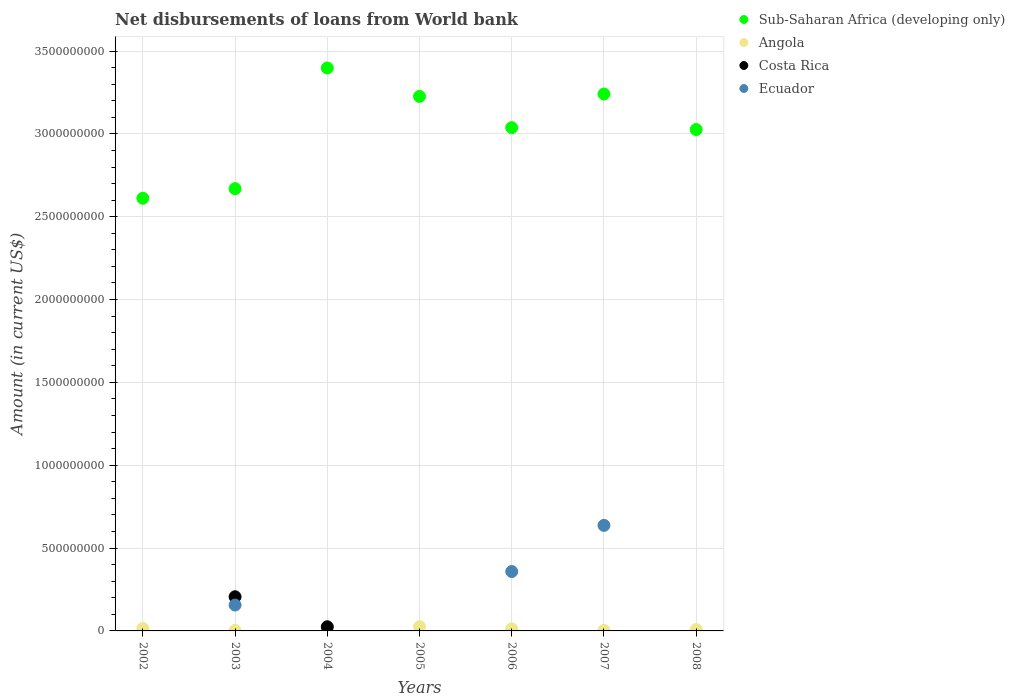What is the amount of loan disbursed from World Bank in Sub-Saharan Africa (developing only) in 2007?
Your answer should be very brief. 3.24e+09. Across all years, what is the maximum amount of loan disbursed from World Bank in Ecuador?
Offer a terse response. 6.37e+08. Across all years, what is the minimum amount of loan disbursed from World Bank in Sub-Saharan Africa (developing only)?
Ensure brevity in your answer.  2.61e+09. What is the total amount of loan disbursed from World Bank in Sub-Saharan Africa (developing only) in the graph?
Your response must be concise. 2.12e+1. What is the difference between the amount of loan disbursed from World Bank in Sub-Saharan Africa (developing only) in 2002 and that in 2008?
Offer a terse response. -4.15e+08. What is the difference between the amount of loan disbursed from World Bank in Costa Rica in 2004 and the amount of loan disbursed from World Bank in Angola in 2005?
Offer a very short reply. -5.76e+05. What is the average amount of loan disbursed from World Bank in Costa Rica per year?
Offer a very short reply. 3.30e+07. In the year 2003, what is the difference between the amount of loan disbursed from World Bank in Costa Rica and amount of loan disbursed from World Bank in Ecuador?
Provide a succinct answer. 5.00e+07. What is the ratio of the amount of loan disbursed from World Bank in Angola in 2004 to that in 2008?
Your answer should be very brief. 2.02. Is the amount of loan disbursed from World Bank in Ecuador in 2006 less than that in 2007?
Make the answer very short. Yes. What is the difference between the highest and the second highest amount of loan disbursed from World Bank in Sub-Saharan Africa (developing only)?
Keep it short and to the point. 1.57e+08. What is the difference between the highest and the lowest amount of loan disbursed from World Bank in Ecuador?
Give a very brief answer. 6.37e+08. Is it the case that in every year, the sum of the amount of loan disbursed from World Bank in Ecuador and amount of loan disbursed from World Bank in Angola  is greater than the sum of amount of loan disbursed from World Bank in Costa Rica and amount of loan disbursed from World Bank in Sub-Saharan Africa (developing only)?
Your answer should be very brief. Yes. Does the amount of loan disbursed from World Bank in Costa Rica monotonically increase over the years?
Your answer should be compact. No. Is the amount of loan disbursed from World Bank in Sub-Saharan Africa (developing only) strictly less than the amount of loan disbursed from World Bank in Angola over the years?
Ensure brevity in your answer.  No. How many dotlines are there?
Provide a succinct answer. 4. Are the values on the major ticks of Y-axis written in scientific E-notation?
Offer a terse response. No. Does the graph contain grids?
Provide a short and direct response. Yes. How many legend labels are there?
Provide a succinct answer. 4. What is the title of the graph?
Your answer should be very brief. Net disbursements of loans from World bank. What is the label or title of the X-axis?
Offer a terse response. Years. What is the label or title of the Y-axis?
Offer a terse response. Amount (in current US$). What is the Amount (in current US$) of Sub-Saharan Africa (developing only) in 2002?
Ensure brevity in your answer.  2.61e+09. What is the Amount (in current US$) in Angola in 2002?
Give a very brief answer. 1.49e+07. What is the Amount (in current US$) of Costa Rica in 2002?
Your answer should be very brief. 0. What is the Amount (in current US$) of Sub-Saharan Africa (developing only) in 2003?
Offer a very short reply. 2.67e+09. What is the Amount (in current US$) in Angola in 2003?
Your answer should be compact. 3.14e+06. What is the Amount (in current US$) of Costa Rica in 2003?
Your answer should be very brief. 2.06e+08. What is the Amount (in current US$) in Ecuador in 2003?
Your answer should be very brief. 1.56e+08. What is the Amount (in current US$) in Sub-Saharan Africa (developing only) in 2004?
Your answer should be compact. 3.40e+09. What is the Amount (in current US$) in Angola in 2004?
Provide a succinct answer. 1.61e+07. What is the Amount (in current US$) of Costa Rica in 2004?
Make the answer very short. 2.51e+07. What is the Amount (in current US$) in Sub-Saharan Africa (developing only) in 2005?
Provide a succinct answer. 3.23e+09. What is the Amount (in current US$) in Angola in 2005?
Your answer should be compact. 2.57e+07. What is the Amount (in current US$) of Ecuador in 2005?
Your response must be concise. 0. What is the Amount (in current US$) of Sub-Saharan Africa (developing only) in 2006?
Keep it short and to the point. 3.04e+09. What is the Amount (in current US$) of Angola in 2006?
Provide a succinct answer. 1.25e+07. What is the Amount (in current US$) of Costa Rica in 2006?
Keep it short and to the point. 0. What is the Amount (in current US$) in Ecuador in 2006?
Provide a succinct answer. 3.58e+08. What is the Amount (in current US$) in Sub-Saharan Africa (developing only) in 2007?
Keep it short and to the point. 3.24e+09. What is the Amount (in current US$) of Angola in 2007?
Offer a terse response. 3.36e+06. What is the Amount (in current US$) in Ecuador in 2007?
Ensure brevity in your answer.  6.37e+08. What is the Amount (in current US$) in Sub-Saharan Africa (developing only) in 2008?
Offer a very short reply. 3.03e+09. What is the Amount (in current US$) of Angola in 2008?
Provide a short and direct response. 7.97e+06. Across all years, what is the maximum Amount (in current US$) of Sub-Saharan Africa (developing only)?
Ensure brevity in your answer.  3.40e+09. Across all years, what is the maximum Amount (in current US$) in Angola?
Make the answer very short. 2.57e+07. Across all years, what is the maximum Amount (in current US$) in Costa Rica?
Ensure brevity in your answer.  2.06e+08. Across all years, what is the maximum Amount (in current US$) in Ecuador?
Make the answer very short. 6.37e+08. Across all years, what is the minimum Amount (in current US$) of Sub-Saharan Africa (developing only)?
Your response must be concise. 2.61e+09. Across all years, what is the minimum Amount (in current US$) in Angola?
Ensure brevity in your answer.  3.14e+06. Across all years, what is the minimum Amount (in current US$) in Costa Rica?
Provide a succinct answer. 0. What is the total Amount (in current US$) in Sub-Saharan Africa (developing only) in the graph?
Offer a very short reply. 2.12e+1. What is the total Amount (in current US$) in Angola in the graph?
Provide a succinct answer. 8.37e+07. What is the total Amount (in current US$) in Costa Rica in the graph?
Make the answer very short. 2.31e+08. What is the total Amount (in current US$) in Ecuador in the graph?
Provide a succinct answer. 1.15e+09. What is the difference between the Amount (in current US$) in Sub-Saharan Africa (developing only) in 2002 and that in 2003?
Give a very brief answer. -5.79e+07. What is the difference between the Amount (in current US$) of Angola in 2002 and that in 2003?
Ensure brevity in your answer.  1.18e+07. What is the difference between the Amount (in current US$) of Sub-Saharan Africa (developing only) in 2002 and that in 2004?
Ensure brevity in your answer.  -7.86e+08. What is the difference between the Amount (in current US$) in Angola in 2002 and that in 2004?
Give a very brief answer. -1.17e+06. What is the difference between the Amount (in current US$) in Sub-Saharan Africa (developing only) in 2002 and that in 2005?
Make the answer very short. -6.15e+08. What is the difference between the Amount (in current US$) in Angola in 2002 and that in 2005?
Make the answer very short. -1.07e+07. What is the difference between the Amount (in current US$) of Sub-Saharan Africa (developing only) in 2002 and that in 2006?
Your answer should be compact. -4.26e+08. What is the difference between the Amount (in current US$) in Angola in 2002 and that in 2006?
Your answer should be compact. 2.41e+06. What is the difference between the Amount (in current US$) of Sub-Saharan Africa (developing only) in 2002 and that in 2007?
Ensure brevity in your answer.  -6.29e+08. What is the difference between the Amount (in current US$) in Angola in 2002 and that in 2007?
Your answer should be very brief. 1.16e+07. What is the difference between the Amount (in current US$) in Sub-Saharan Africa (developing only) in 2002 and that in 2008?
Give a very brief answer. -4.15e+08. What is the difference between the Amount (in current US$) of Angola in 2002 and that in 2008?
Provide a succinct answer. 6.97e+06. What is the difference between the Amount (in current US$) of Sub-Saharan Africa (developing only) in 2003 and that in 2004?
Provide a short and direct response. -7.28e+08. What is the difference between the Amount (in current US$) of Angola in 2003 and that in 2004?
Keep it short and to the point. -1.30e+07. What is the difference between the Amount (in current US$) of Costa Rica in 2003 and that in 2004?
Give a very brief answer. 1.81e+08. What is the difference between the Amount (in current US$) of Sub-Saharan Africa (developing only) in 2003 and that in 2005?
Make the answer very short. -5.57e+08. What is the difference between the Amount (in current US$) in Angola in 2003 and that in 2005?
Ensure brevity in your answer.  -2.25e+07. What is the difference between the Amount (in current US$) in Sub-Saharan Africa (developing only) in 2003 and that in 2006?
Your answer should be compact. -3.68e+08. What is the difference between the Amount (in current US$) in Angola in 2003 and that in 2006?
Give a very brief answer. -9.39e+06. What is the difference between the Amount (in current US$) of Ecuador in 2003 and that in 2006?
Give a very brief answer. -2.02e+08. What is the difference between the Amount (in current US$) in Sub-Saharan Africa (developing only) in 2003 and that in 2007?
Your answer should be very brief. -5.71e+08. What is the difference between the Amount (in current US$) of Angola in 2003 and that in 2007?
Your answer should be compact. -2.14e+05. What is the difference between the Amount (in current US$) in Ecuador in 2003 and that in 2007?
Give a very brief answer. -4.81e+08. What is the difference between the Amount (in current US$) in Sub-Saharan Africa (developing only) in 2003 and that in 2008?
Give a very brief answer. -3.57e+08. What is the difference between the Amount (in current US$) in Angola in 2003 and that in 2008?
Your answer should be compact. -4.82e+06. What is the difference between the Amount (in current US$) of Sub-Saharan Africa (developing only) in 2004 and that in 2005?
Your answer should be very brief. 1.71e+08. What is the difference between the Amount (in current US$) in Angola in 2004 and that in 2005?
Your response must be concise. -9.56e+06. What is the difference between the Amount (in current US$) in Sub-Saharan Africa (developing only) in 2004 and that in 2006?
Your answer should be compact. 3.60e+08. What is the difference between the Amount (in current US$) in Angola in 2004 and that in 2006?
Make the answer very short. 3.57e+06. What is the difference between the Amount (in current US$) of Sub-Saharan Africa (developing only) in 2004 and that in 2007?
Provide a succinct answer. 1.57e+08. What is the difference between the Amount (in current US$) of Angola in 2004 and that in 2007?
Keep it short and to the point. 1.28e+07. What is the difference between the Amount (in current US$) in Sub-Saharan Africa (developing only) in 2004 and that in 2008?
Your answer should be compact. 3.71e+08. What is the difference between the Amount (in current US$) in Angola in 2004 and that in 2008?
Make the answer very short. 8.14e+06. What is the difference between the Amount (in current US$) in Sub-Saharan Africa (developing only) in 2005 and that in 2006?
Your answer should be compact. 1.89e+08. What is the difference between the Amount (in current US$) of Angola in 2005 and that in 2006?
Ensure brevity in your answer.  1.31e+07. What is the difference between the Amount (in current US$) in Sub-Saharan Africa (developing only) in 2005 and that in 2007?
Keep it short and to the point. -1.42e+07. What is the difference between the Amount (in current US$) in Angola in 2005 and that in 2007?
Give a very brief answer. 2.23e+07. What is the difference between the Amount (in current US$) of Sub-Saharan Africa (developing only) in 2005 and that in 2008?
Ensure brevity in your answer.  2.00e+08. What is the difference between the Amount (in current US$) of Angola in 2005 and that in 2008?
Your answer should be compact. 1.77e+07. What is the difference between the Amount (in current US$) of Sub-Saharan Africa (developing only) in 2006 and that in 2007?
Offer a very short reply. -2.03e+08. What is the difference between the Amount (in current US$) in Angola in 2006 and that in 2007?
Offer a very short reply. 9.18e+06. What is the difference between the Amount (in current US$) of Ecuador in 2006 and that in 2007?
Your response must be concise. -2.79e+08. What is the difference between the Amount (in current US$) of Sub-Saharan Africa (developing only) in 2006 and that in 2008?
Provide a short and direct response. 1.14e+07. What is the difference between the Amount (in current US$) in Angola in 2006 and that in 2008?
Provide a succinct answer. 4.57e+06. What is the difference between the Amount (in current US$) in Sub-Saharan Africa (developing only) in 2007 and that in 2008?
Give a very brief answer. 2.14e+08. What is the difference between the Amount (in current US$) in Angola in 2007 and that in 2008?
Keep it short and to the point. -4.61e+06. What is the difference between the Amount (in current US$) in Sub-Saharan Africa (developing only) in 2002 and the Amount (in current US$) in Angola in 2003?
Offer a terse response. 2.61e+09. What is the difference between the Amount (in current US$) of Sub-Saharan Africa (developing only) in 2002 and the Amount (in current US$) of Costa Rica in 2003?
Keep it short and to the point. 2.41e+09. What is the difference between the Amount (in current US$) in Sub-Saharan Africa (developing only) in 2002 and the Amount (in current US$) in Ecuador in 2003?
Ensure brevity in your answer.  2.46e+09. What is the difference between the Amount (in current US$) of Angola in 2002 and the Amount (in current US$) of Costa Rica in 2003?
Provide a short and direct response. -1.91e+08. What is the difference between the Amount (in current US$) of Angola in 2002 and the Amount (in current US$) of Ecuador in 2003?
Provide a short and direct response. -1.41e+08. What is the difference between the Amount (in current US$) of Sub-Saharan Africa (developing only) in 2002 and the Amount (in current US$) of Angola in 2004?
Your response must be concise. 2.60e+09. What is the difference between the Amount (in current US$) in Sub-Saharan Africa (developing only) in 2002 and the Amount (in current US$) in Costa Rica in 2004?
Make the answer very short. 2.59e+09. What is the difference between the Amount (in current US$) in Angola in 2002 and the Amount (in current US$) in Costa Rica in 2004?
Provide a succinct answer. -1.01e+07. What is the difference between the Amount (in current US$) in Sub-Saharan Africa (developing only) in 2002 and the Amount (in current US$) in Angola in 2005?
Provide a short and direct response. 2.59e+09. What is the difference between the Amount (in current US$) of Sub-Saharan Africa (developing only) in 2002 and the Amount (in current US$) of Angola in 2006?
Your answer should be compact. 2.60e+09. What is the difference between the Amount (in current US$) of Sub-Saharan Africa (developing only) in 2002 and the Amount (in current US$) of Ecuador in 2006?
Your answer should be very brief. 2.25e+09. What is the difference between the Amount (in current US$) in Angola in 2002 and the Amount (in current US$) in Ecuador in 2006?
Your response must be concise. -3.43e+08. What is the difference between the Amount (in current US$) in Sub-Saharan Africa (developing only) in 2002 and the Amount (in current US$) in Angola in 2007?
Provide a short and direct response. 2.61e+09. What is the difference between the Amount (in current US$) of Sub-Saharan Africa (developing only) in 2002 and the Amount (in current US$) of Ecuador in 2007?
Give a very brief answer. 1.97e+09. What is the difference between the Amount (in current US$) of Angola in 2002 and the Amount (in current US$) of Ecuador in 2007?
Provide a succinct answer. -6.22e+08. What is the difference between the Amount (in current US$) of Sub-Saharan Africa (developing only) in 2002 and the Amount (in current US$) of Angola in 2008?
Provide a short and direct response. 2.60e+09. What is the difference between the Amount (in current US$) of Sub-Saharan Africa (developing only) in 2003 and the Amount (in current US$) of Angola in 2004?
Provide a short and direct response. 2.65e+09. What is the difference between the Amount (in current US$) of Sub-Saharan Africa (developing only) in 2003 and the Amount (in current US$) of Costa Rica in 2004?
Ensure brevity in your answer.  2.64e+09. What is the difference between the Amount (in current US$) of Angola in 2003 and the Amount (in current US$) of Costa Rica in 2004?
Provide a short and direct response. -2.19e+07. What is the difference between the Amount (in current US$) of Sub-Saharan Africa (developing only) in 2003 and the Amount (in current US$) of Angola in 2005?
Ensure brevity in your answer.  2.64e+09. What is the difference between the Amount (in current US$) of Sub-Saharan Africa (developing only) in 2003 and the Amount (in current US$) of Angola in 2006?
Ensure brevity in your answer.  2.66e+09. What is the difference between the Amount (in current US$) in Sub-Saharan Africa (developing only) in 2003 and the Amount (in current US$) in Ecuador in 2006?
Ensure brevity in your answer.  2.31e+09. What is the difference between the Amount (in current US$) of Angola in 2003 and the Amount (in current US$) of Ecuador in 2006?
Make the answer very short. -3.55e+08. What is the difference between the Amount (in current US$) in Costa Rica in 2003 and the Amount (in current US$) in Ecuador in 2006?
Your response must be concise. -1.52e+08. What is the difference between the Amount (in current US$) in Sub-Saharan Africa (developing only) in 2003 and the Amount (in current US$) in Angola in 2007?
Ensure brevity in your answer.  2.67e+09. What is the difference between the Amount (in current US$) of Sub-Saharan Africa (developing only) in 2003 and the Amount (in current US$) of Ecuador in 2007?
Make the answer very short. 2.03e+09. What is the difference between the Amount (in current US$) of Angola in 2003 and the Amount (in current US$) of Ecuador in 2007?
Give a very brief answer. -6.34e+08. What is the difference between the Amount (in current US$) in Costa Rica in 2003 and the Amount (in current US$) in Ecuador in 2007?
Provide a short and direct response. -4.31e+08. What is the difference between the Amount (in current US$) of Sub-Saharan Africa (developing only) in 2003 and the Amount (in current US$) of Angola in 2008?
Your answer should be compact. 2.66e+09. What is the difference between the Amount (in current US$) in Sub-Saharan Africa (developing only) in 2004 and the Amount (in current US$) in Angola in 2005?
Provide a short and direct response. 3.37e+09. What is the difference between the Amount (in current US$) of Sub-Saharan Africa (developing only) in 2004 and the Amount (in current US$) of Angola in 2006?
Your response must be concise. 3.39e+09. What is the difference between the Amount (in current US$) in Sub-Saharan Africa (developing only) in 2004 and the Amount (in current US$) in Ecuador in 2006?
Make the answer very short. 3.04e+09. What is the difference between the Amount (in current US$) of Angola in 2004 and the Amount (in current US$) of Ecuador in 2006?
Provide a short and direct response. -3.42e+08. What is the difference between the Amount (in current US$) in Costa Rica in 2004 and the Amount (in current US$) in Ecuador in 2006?
Provide a short and direct response. -3.33e+08. What is the difference between the Amount (in current US$) of Sub-Saharan Africa (developing only) in 2004 and the Amount (in current US$) of Angola in 2007?
Your answer should be very brief. 3.39e+09. What is the difference between the Amount (in current US$) of Sub-Saharan Africa (developing only) in 2004 and the Amount (in current US$) of Ecuador in 2007?
Keep it short and to the point. 2.76e+09. What is the difference between the Amount (in current US$) of Angola in 2004 and the Amount (in current US$) of Ecuador in 2007?
Provide a short and direct response. -6.21e+08. What is the difference between the Amount (in current US$) of Costa Rica in 2004 and the Amount (in current US$) of Ecuador in 2007?
Provide a short and direct response. -6.12e+08. What is the difference between the Amount (in current US$) of Sub-Saharan Africa (developing only) in 2004 and the Amount (in current US$) of Angola in 2008?
Your answer should be very brief. 3.39e+09. What is the difference between the Amount (in current US$) in Sub-Saharan Africa (developing only) in 2005 and the Amount (in current US$) in Angola in 2006?
Ensure brevity in your answer.  3.21e+09. What is the difference between the Amount (in current US$) in Sub-Saharan Africa (developing only) in 2005 and the Amount (in current US$) in Ecuador in 2006?
Offer a terse response. 2.87e+09. What is the difference between the Amount (in current US$) in Angola in 2005 and the Amount (in current US$) in Ecuador in 2006?
Ensure brevity in your answer.  -3.33e+08. What is the difference between the Amount (in current US$) in Sub-Saharan Africa (developing only) in 2005 and the Amount (in current US$) in Angola in 2007?
Provide a short and direct response. 3.22e+09. What is the difference between the Amount (in current US$) in Sub-Saharan Africa (developing only) in 2005 and the Amount (in current US$) in Ecuador in 2007?
Your answer should be compact. 2.59e+09. What is the difference between the Amount (in current US$) of Angola in 2005 and the Amount (in current US$) of Ecuador in 2007?
Give a very brief answer. -6.11e+08. What is the difference between the Amount (in current US$) of Sub-Saharan Africa (developing only) in 2005 and the Amount (in current US$) of Angola in 2008?
Make the answer very short. 3.22e+09. What is the difference between the Amount (in current US$) of Sub-Saharan Africa (developing only) in 2006 and the Amount (in current US$) of Angola in 2007?
Provide a short and direct response. 3.03e+09. What is the difference between the Amount (in current US$) in Sub-Saharan Africa (developing only) in 2006 and the Amount (in current US$) in Ecuador in 2007?
Give a very brief answer. 2.40e+09. What is the difference between the Amount (in current US$) in Angola in 2006 and the Amount (in current US$) in Ecuador in 2007?
Ensure brevity in your answer.  -6.24e+08. What is the difference between the Amount (in current US$) in Sub-Saharan Africa (developing only) in 2006 and the Amount (in current US$) in Angola in 2008?
Your answer should be very brief. 3.03e+09. What is the difference between the Amount (in current US$) of Sub-Saharan Africa (developing only) in 2007 and the Amount (in current US$) of Angola in 2008?
Provide a succinct answer. 3.23e+09. What is the average Amount (in current US$) in Sub-Saharan Africa (developing only) per year?
Ensure brevity in your answer.  3.03e+09. What is the average Amount (in current US$) in Angola per year?
Make the answer very short. 1.20e+07. What is the average Amount (in current US$) of Costa Rica per year?
Offer a very short reply. 3.30e+07. What is the average Amount (in current US$) of Ecuador per year?
Ensure brevity in your answer.  1.65e+08. In the year 2002, what is the difference between the Amount (in current US$) in Sub-Saharan Africa (developing only) and Amount (in current US$) in Angola?
Keep it short and to the point. 2.60e+09. In the year 2003, what is the difference between the Amount (in current US$) of Sub-Saharan Africa (developing only) and Amount (in current US$) of Angola?
Your answer should be compact. 2.67e+09. In the year 2003, what is the difference between the Amount (in current US$) in Sub-Saharan Africa (developing only) and Amount (in current US$) in Costa Rica?
Your answer should be compact. 2.46e+09. In the year 2003, what is the difference between the Amount (in current US$) in Sub-Saharan Africa (developing only) and Amount (in current US$) in Ecuador?
Your answer should be very brief. 2.51e+09. In the year 2003, what is the difference between the Amount (in current US$) in Angola and Amount (in current US$) in Costa Rica?
Keep it short and to the point. -2.03e+08. In the year 2003, what is the difference between the Amount (in current US$) in Angola and Amount (in current US$) in Ecuador?
Ensure brevity in your answer.  -1.53e+08. In the year 2003, what is the difference between the Amount (in current US$) of Costa Rica and Amount (in current US$) of Ecuador?
Provide a succinct answer. 5.00e+07. In the year 2004, what is the difference between the Amount (in current US$) of Sub-Saharan Africa (developing only) and Amount (in current US$) of Angola?
Provide a short and direct response. 3.38e+09. In the year 2004, what is the difference between the Amount (in current US$) of Sub-Saharan Africa (developing only) and Amount (in current US$) of Costa Rica?
Give a very brief answer. 3.37e+09. In the year 2004, what is the difference between the Amount (in current US$) in Angola and Amount (in current US$) in Costa Rica?
Your answer should be very brief. -8.98e+06. In the year 2005, what is the difference between the Amount (in current US$) of Sub-Saharan Africa (developing only) and Amount (in current US$) of Angola?
Offer a terse response. 3.20e+09. In the year 2006, what is the difference between the Amount (in current US$) in Sub-Saharan Africa (developing only) and Amount (in current US$) in Angola?
Your answer should be compact. 3.03e+09. In the year 2006, what is the difference between the Amount (in current US$) of Sub-Saharan Africa (developing only) and Amount (in current US$) of Ecuador?
Provide a succinct answer. 2.68e+09. In the year 2006, what is the difference between the Amount (in current US$) in Angola and Amount (in current US$) in Ecuador?
Give a very brief answer. -3.46e+08. In the year 2007, what is the difference between the Amount (in current US$) in Sub-Saharan Africa (developing only) and Amount (in current US$) in Angola?
Ensure brevity in your answer.  3.24e+09. In the year 2007, what is the difference between the Amount (in current US$) in Sub-Saharan Africa (developing only) and Amount (in current US$) in Ecuador?
Offer a terse response. 2.60e+09. In the year 2007, what is the difference between the Amount (in current US$) in Angola and Amount (in current US$) in Ecuador?
Give a very brief answer. -6.34e+08. In the year 2008, what is the difference between the Amount (in current US$) of Sub-Saharan Africa (developing only) and Amount (in current US$) of Angola?
Provide a succinct answer. 3.02e+09. What is the ratio of the Amount (in current US$) of Sub-Saharan Africa (developing only) in 2002 to that in 2003?
Offer a terse response. 0.98. What is the ratio of the Amount (in current US$) of Angola in 2002 to that in 2003?
Make the answer very short. 4.75. What is the ratio of the Amount (in current US$) in Sub-Saharan Africa (developing only) in 2002 to that in 2004?
Your response must be concise. 0.77. What is the ratio of the Amount (in current US$) in Angola in 2002 to that in 2004?
Your answer should be very brief. 0.93. What is the ratio of the Amount (in current US$) of Sub-Saharan Africa (developing only) in 2002 to that in 2005?
Your response must be concise. 0.81. What is the ratio of the Amount (in current US$) in Angola in 2002 to that in 2005?
Offer a terse response. 0.58. What is the ratio of the Amount (in current US$) in Sub-Saharan Africa (developing only) in 2002 to that in 2006?
Your response must be concise. 0.86. What is the ratio of the Amount (in current US$) of Angola in 2002 to that in 2006?
Make the answer very short. 1.19. What is the ratio of the Amount (in current US$) in Sub-Saharan Africa (developing only) in 2002 to that in 2007?
Your answer should be very brief. 0.81. What is the ratio of the Amount (in current US$) of Angola in 2002 to that in 2007?
Provide a succinct answer. 4.45. What is the ratio of the Amount (in current US$) in Sub-Saharan Africa (developing only) in 2002 to that in 2008?
Your answer should be very brief. 0.86. What is the ratio of the Amount (in current US$) in Angola in 2002 to that in 2008?
Make the answer very short. 1.88. What is the ratio of the Amount (in current US$) of Sub-Saharan Africa (developing only) in 2003 to that in 2004?
Ensure brevity in your answer.  0.79. What is the ratio of the Amount (in current US$) in Angola in 2003 to that in 2004?
Ensure brevity in your answer.  0.2. What is the ratio of the Amount (in current US$) of Costa Rica in 2003 to that in 2004?
Make the answer very short. 8.22. What is the ratio of the Amount (in current US$) in Sub-Saharan Africa (developing only) in 2003 to that in 2005?
Give a very brief answer. 0.83. What is the ratio of the Amount (in current US$) of Angola in 2003 to that in 2005?
Your answer should be very brief. 0.12. What is the ratio of the Amount (in current US$) of Sub-Saharan Africa (developing only) in 2003 to that in 2006?
Provide a short and direct response. 0.88. What is the ratio of the Amount (in current US$) in Angola in 2003 to that in 2006?
Make the answer very short. 0.25. What is the ratio of the Amount (in current US$) in Ecuador in 2003 to that in 2006?
Your answer should be compact. 0.44. What is the ratio of the Amount (in current US$) of Sub-Saharan Africa (developing only) in 2003 to that in 2007?
Offer a terse response. 0.82. What is the ratio of the Amount (in current US$) of Angola in 2003 to that in 2007?
Provide a succinct answer. 0.94. What is the ratio of the Amount (in current US$) of Ecuador in 2003 to that in 2007?
Provide a short and direct response. 0.25. What is the ratio of the Amount (in current US$) in Sub-Saharan Africa (developing only) in 2003 to that in 2008?
Your response must be concise. 0.88. What is the ratio of the Amount (in current US$) of Angola in 2003 to that in 2008?
Keep it short and to the point. 0.39. What is the ratio of the Amount (in current US$) in Sub-Saharan Africa (developing only) in 2004 to that in 2005?
Your answer should be very brief. 1.05. What is the ratio of the Amount (in current US$) in Angola in 2004 to that in 2005?
Provide a short and direct response. 0.63. What is the ratio of the Amount (in current US$) of Sub-Saharan Africa (developing only) in 2004 to that in 2006?
Your response must be concise. 1.12. What is the ratio of the Amount (in current US$) of Angola in 2004 to that in 2006?
Offer a very short reply. 1.28. What is the ratio of the Amount (in current US$) of Sub-Saharan Africa (developing only) in 2004 to that in 2007?
Your answer should be very brief. 1.05. What is the ratio of the Amount (in current US$) of Angola in 2004 to that in 2007?
Provide a short and direct response. 4.8. What is the ratio of the Amount (in current US$) of Sub-Saharan Africa (developing only) in 2004 to that in 2008?
Make the answer very short. 1.12. What is the ratio of the Amount (in current US$) of Angola in 2004 to that in 2008?
Your response must be concise. 2.02. What is the ratio of the Amount (in current US$) in Sub-Saharan Africa (developing only) in 2005 to that in 2006?
Give a very brief answer. 1.06. What is the ratio of the Amount (in current US$) of Angola in 2005 to that in 2006?
Your answer should be very brief. 2.05. What is the ratio of the Amount (in current US$) in Angola in 2005 to that in 2007?
Your answer should be very brief. 7.64. What is the ratio of the Amount (in current US$) of Sub-Saharan Africa (developing only) in 2005 to that in 2008?
Keep it short and to the point. 1.07. What is the ratio of the Amount (in current US$) of Angola in 2005 to that in 2008?
Your answer should be very brief. 3.22. What is the ratio of the Amount (in current US$) of Sub-Saharan Africa (developing only) in 2006 to that in 2007?
Your answer should be compact. 0.94. What is the ratio of the Amount (in current US$) in Angola in 2006 to that in 2007?
Your answer should be very brief. 3.73. What is the ratio of the Amount (in current US$) of Ecuador in 2006 to that in 2007?
Your answer should be very brief. 0.56. What is the ratio of the Amount (in current US$) of Angola in 2006 to that in 2008?
Provide a short and direct response. 1.57. What is the ratio of the Amount (in current US$) in Sub-Saharan Africa (developing only) in 2007 to that in 2008?
Your answer should be compact. 1.07. What is the ratio of the Amount (in current US$) of Angola in 2007 to that in 2008?
Make the answer very short. 0.42. What is the difference between the highest and the second highest Amount (in current US$) of Sub-Saharan Africa (developing only)?
Offer a terse response. 1.57e+08. What is the difference between the highest and the second highest Amount (in current US$) of Angola?
Provide a succinct answer. 9.56e+06. What is the difference between the highest and the second highest Amount (in current US$) in Ecuador?
Your answer should be compact. 2.79e+08. What is the difference between the highest and the lowest Amount (in current US$) in Sub-Saharan Africa (developing only)?
Provide a short and direct response. 7.86e+08. What is the difference between the highest and the lowest Amount (in current US$) of Angola?
Your response must be concise. 2.25e+07. What is the difference between the highest and the lowest Amount (in current US$) in Costa Rica?
Give a very brief answer. 2.06e+08. What is the difference between the highest and the lowest Amount (in current US$) in Ecuador?
Provide a short and direct response. 6.37e+08. 